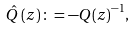<formula> <loc_0><loc_0><loc_500><loc_500>\hat { Q } \left ( z \right ) \colon = - { Q ( z ) } ^ { - 1 } ,</formula> 